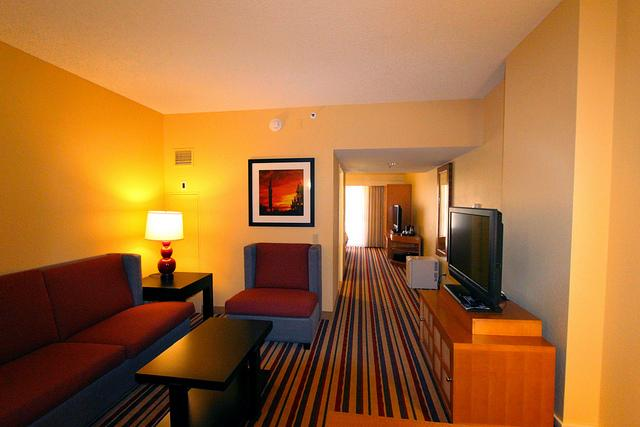What can be done with the appliance in this room? Please explain your reasoning. viewing. It is a television 